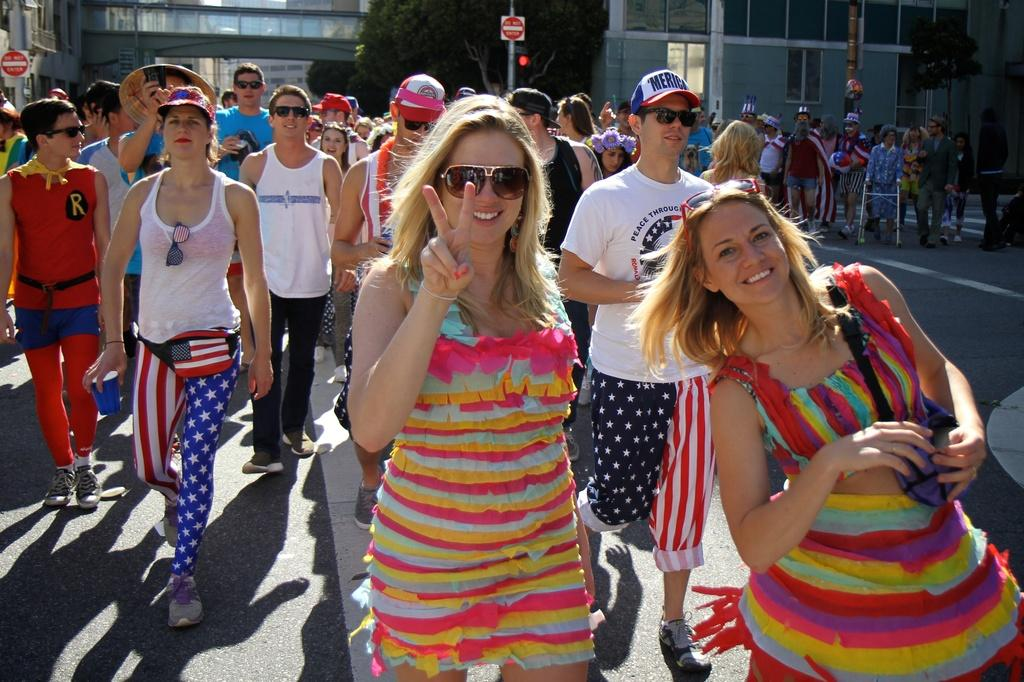What are the people in the image doing? The people in the image are walking. What can be seen in the background of the image? There are sign poles, buildings, and trees in the background of the image. Can you describe the structure at the top side of the image? It appears that there is a bridge at the top side of the image. What type of bubble is floating near the bridge in the image? There is no bubble present in the image. Can you describe the toy that the people are playing with in the image? There is no toy visible in the image; the people are simply walking. 